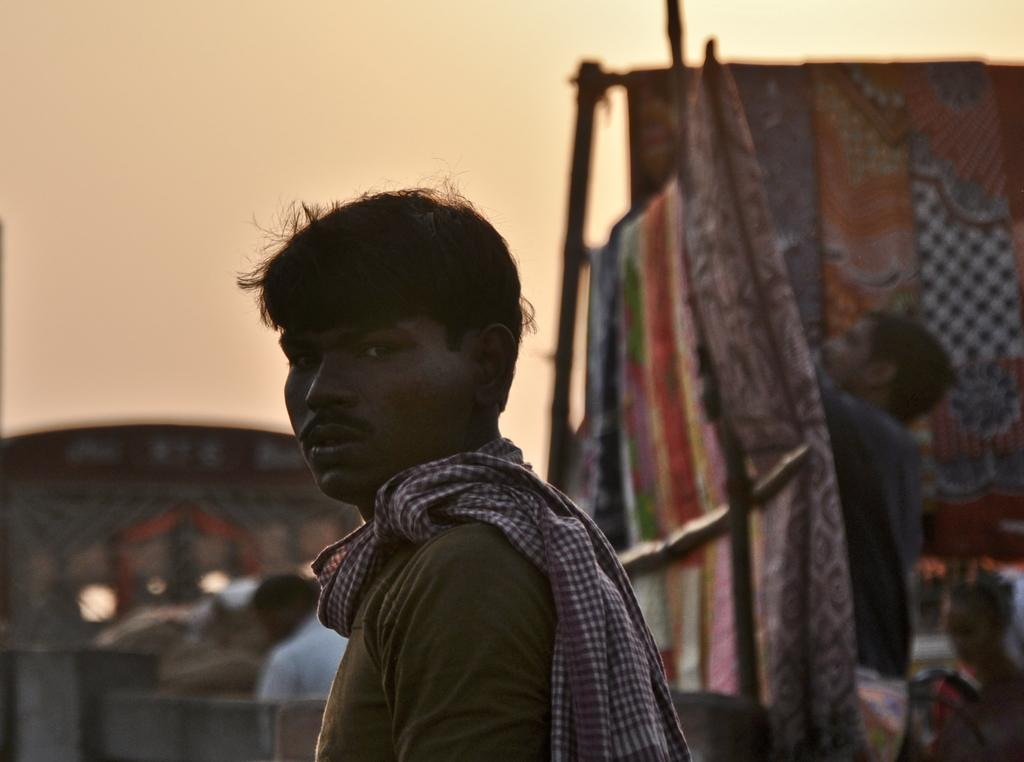Who is the main subject in the image? There is a man in the center of the image. What can be seen in the background of the image? There are clothes, persons, a building, and the sky visible in the background of the image. What type of food is being served in the image? There is no food present in the image. What scientific theory is being discussed by the persons in the background? There is no indication of a scientific discussion or any specific theory being discussed in the image. 